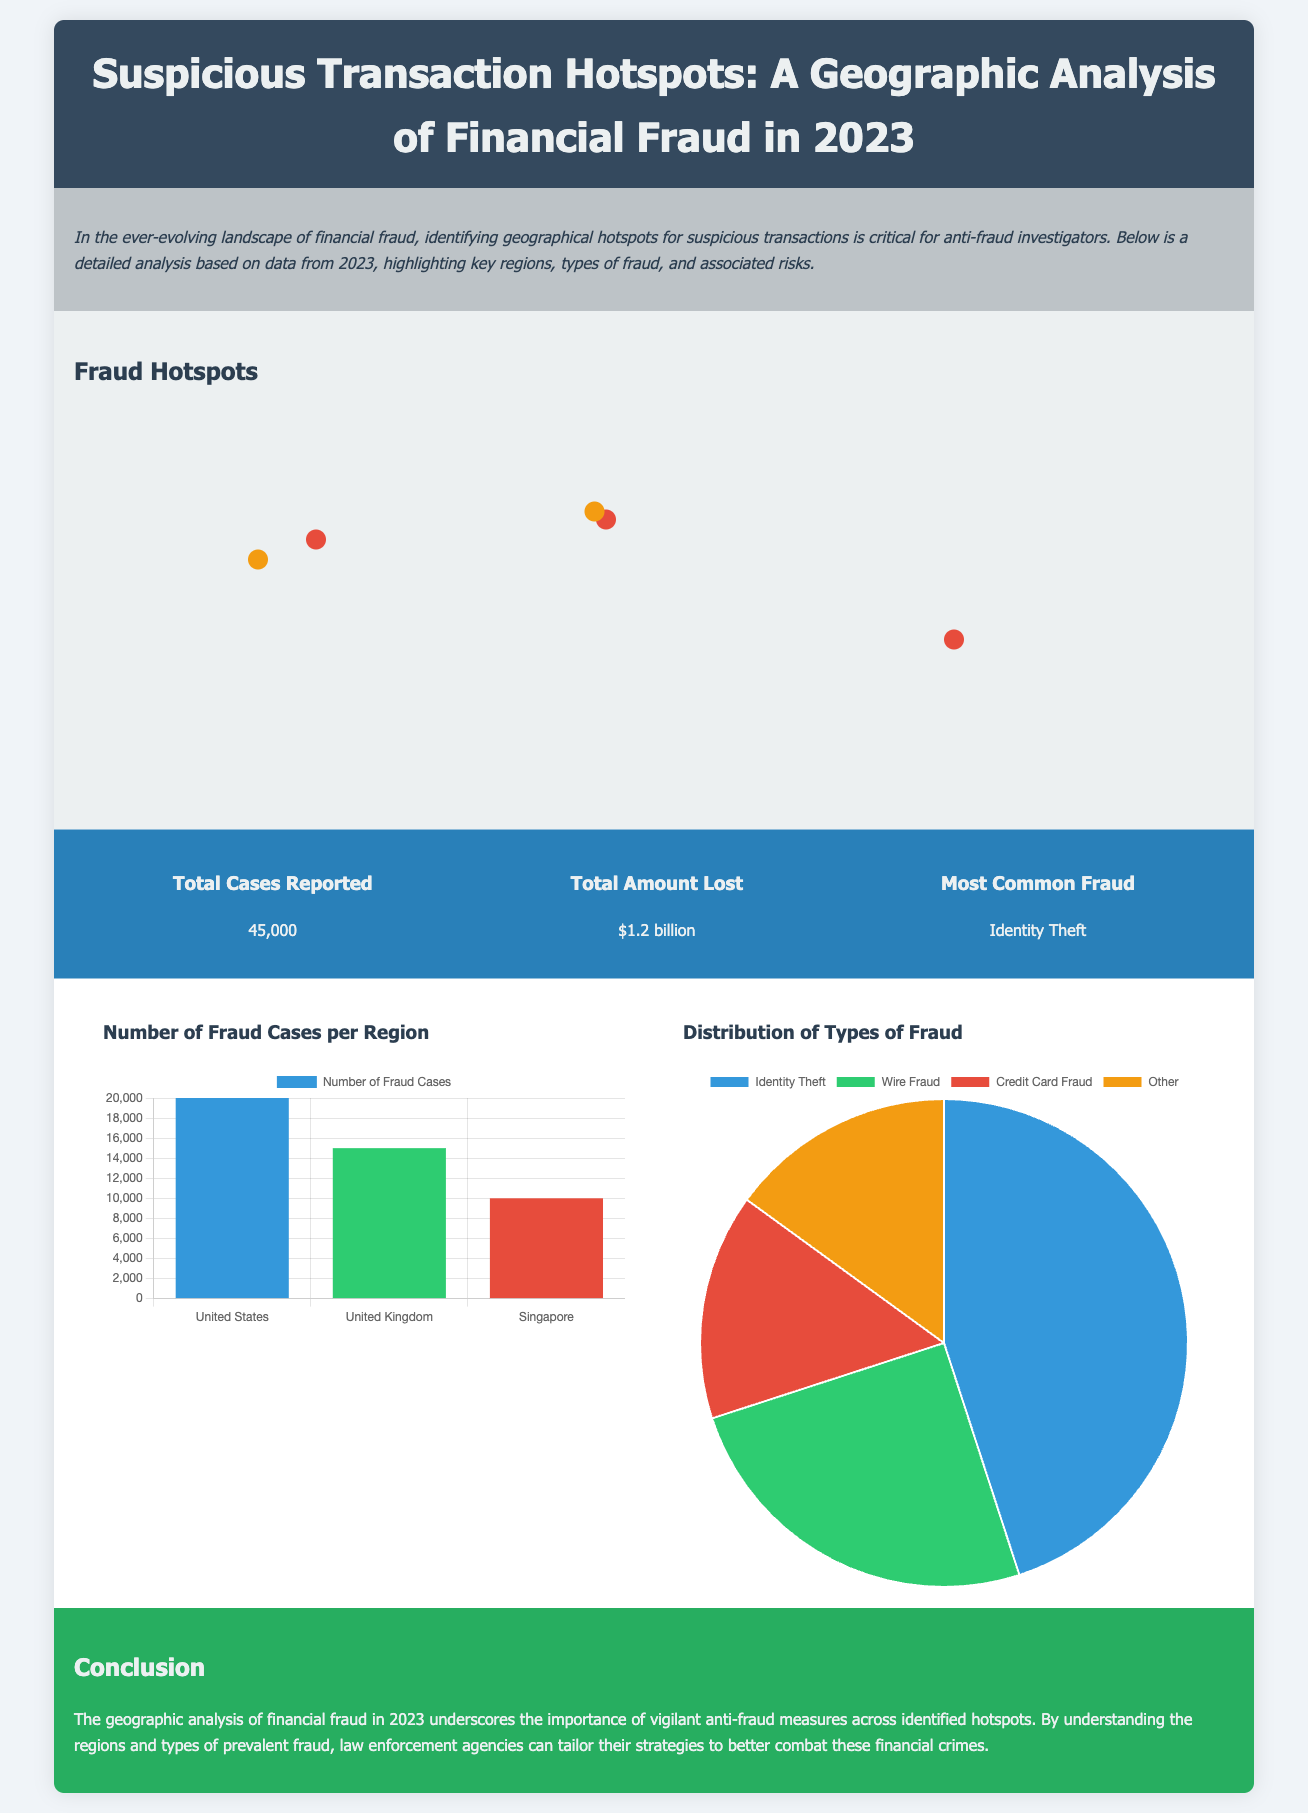what is the title of the document? The title of the document is stated at the top, indicating the focus on suspicious transaction hotspots in financial fraud for the year 2023.
Answer: Suspicious Transaction Hotspots: A Geographic Analysis of Financial Fraud in 2023 how many total cases were reported? The total number of cases reported is highlighted in the statistics section of the document, providing a clear number.
Answer: 45,000 what is the total amount lost due to fraud? The document specifies the total amount lost in the statistics section, which quantifies the financial impact of fraud.
Answer: $1.2 billion which city has high risk for identity theft? The map section identifies specific hotspots and their associated risks, including New York as a high-risk city for identity theft.
Answer: New York what type of fraud is most common? The most common type of fraud is listed in the statistics section, summarizing the prevalent fraud category.
Answer: Identity Theft how many fraud cases were reported in the United Kingdom? The bar chart shows the number of fraud cases reported in various regions, including the UK.
Answer: 15,000 which type of fraud has the highest distribution percentage? The pie chart represents the distribution of different types of fraud, highlighting the one with the highest percentage.
Answer: Identity Theft what color represents high-risk hotspots on the map? The document describes the color coding used for hotspots, specifically indicating which color represents high risk.
Answer: Red what conclusion is drawn about the geographic analysis? The conclusion summarizes the overall findings and emphasizes the importance of anti-fraud measures based on regional analysis.
Answer: Tailored strategies to combat financial crimes 